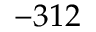<formula> <loc_0><loc_0><loc_500><loc_500>- 3 1 2</formula> 